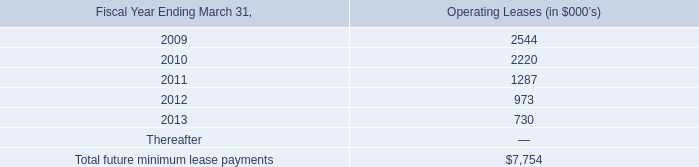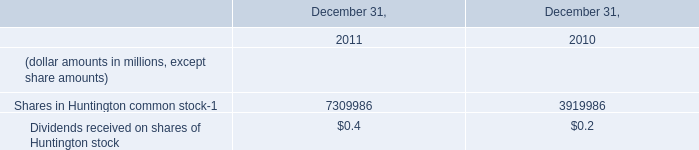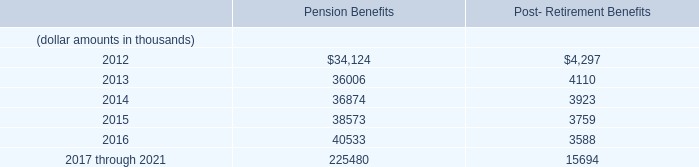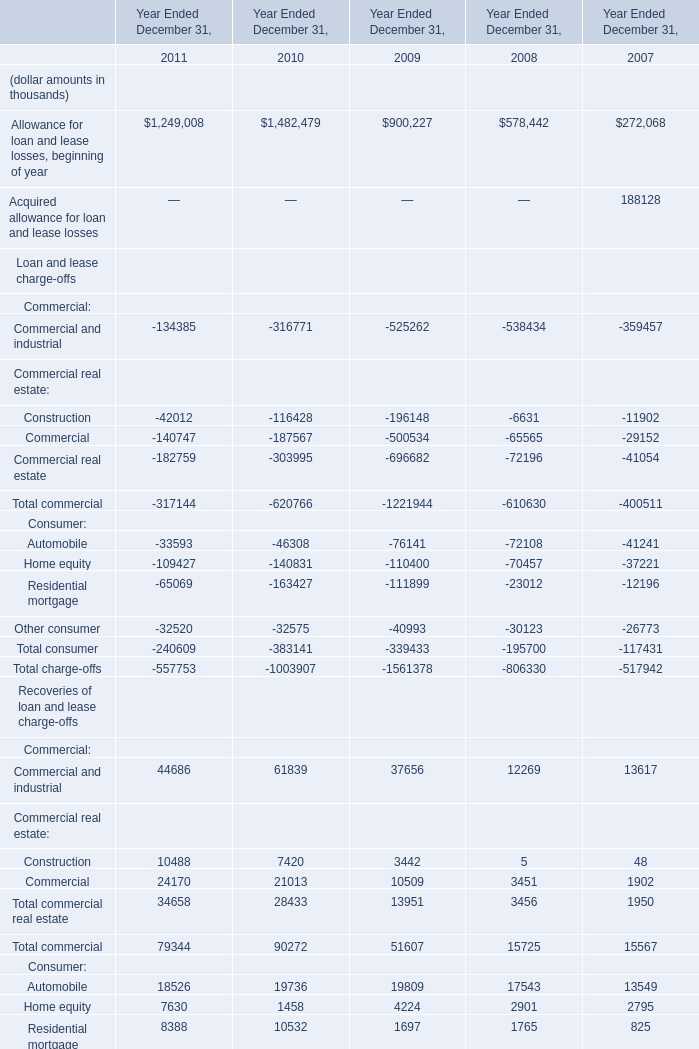In the year with largest amount of Total recoveries, what's the value of Allowance for loan and lease losses, beginning of year ? (in thousand) 
Answer: 1482479. 